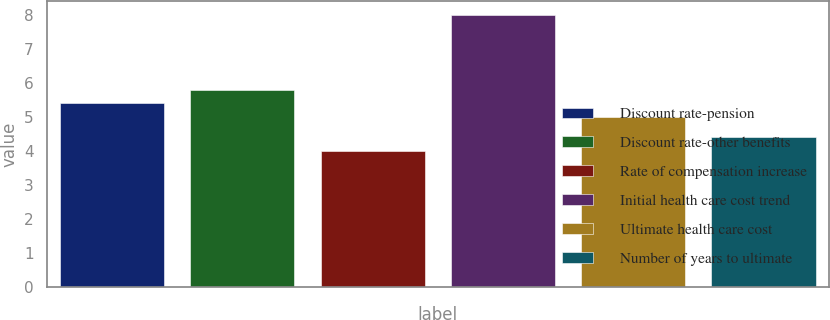<chart> <loc_0><loc_0><loc_500><loc_500><bar_chart><fcel>Discount rate-pension<fcel>Discount rate-other benefits<fcel>Rate of compensation increase<fcel>Initial health care cost trend<fcel>Ultimate health care cost<fcel>Number of years to ultimate<nl><fcel>5.4<fcel>5.8<fcel>4<fcel>8<fcel>5<fcel>4.4<nl></chart> 